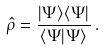<formula> <loc_0><loc_0><loc_500><loc_500>\hat { \rho } = \frac { | \Psi \rangle \langle \Psi | } { \langle \Psi | \Psi \rangle } \, .</formula> 